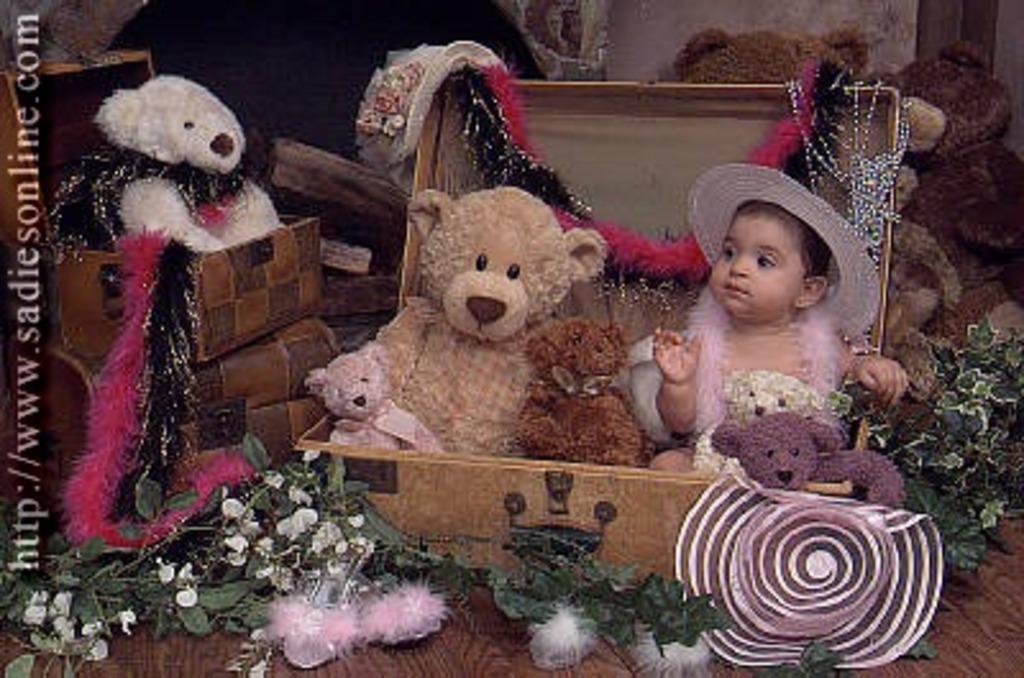Describe this image in one or two sentences. In the picture there are many toys present, there is a baby present. 